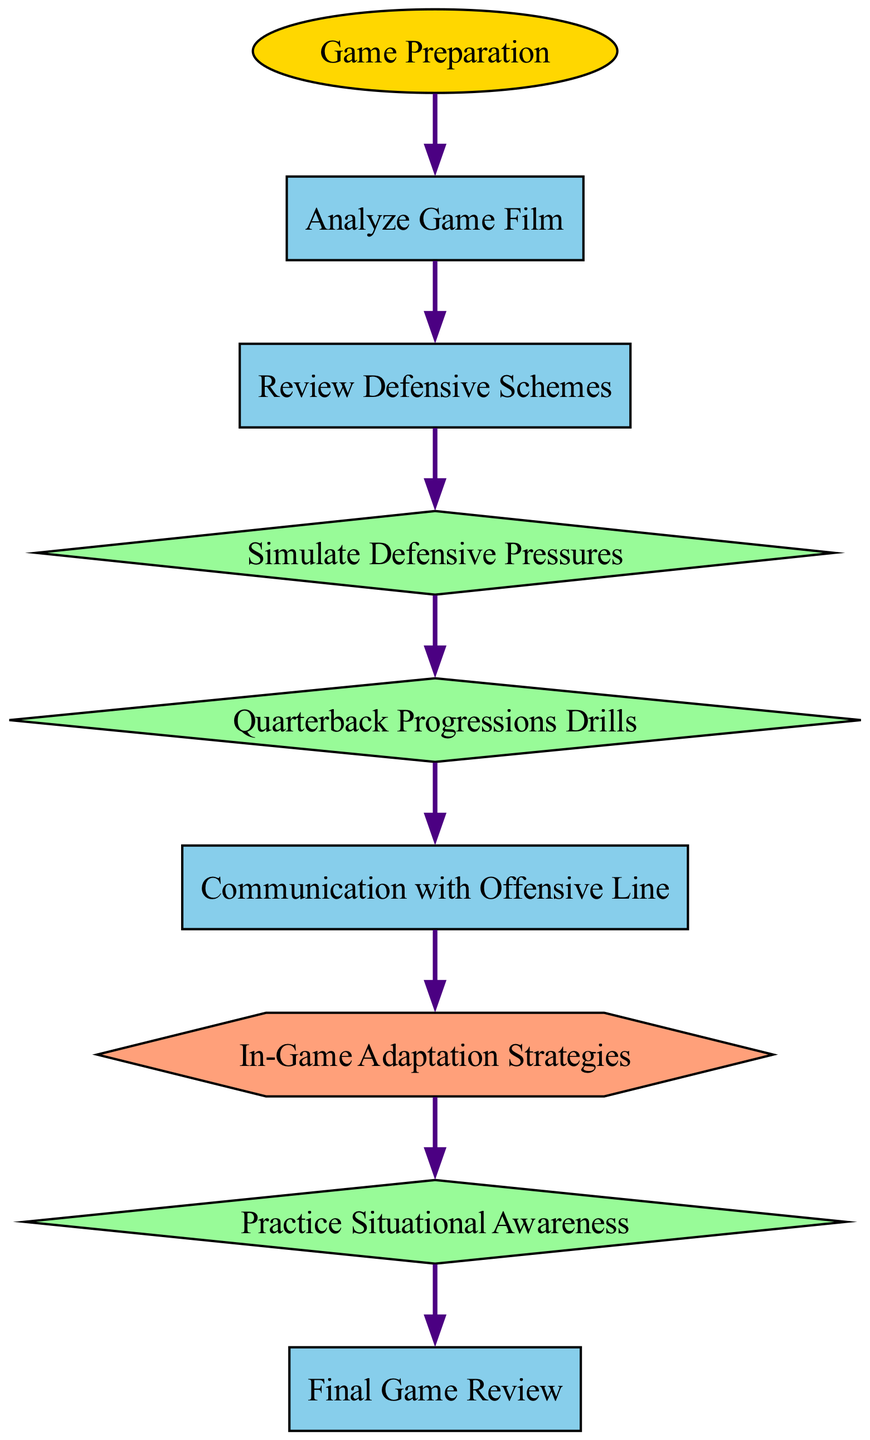What is the first activity in the preparation flow? The first activity is "Analyze Game Film," which is directly dependent on the "Game Preparation" process.
Answer: Analyze Game Film How many drills are included in the preparation flow? There are three drills present in the flow: "Simulate Defensive Pressures," "Quarterback Progressions Drills," and "Practice Situational Awareness."
Answer: Three What is the connection between "In-Game Adaptation Strategies" and "Communication with Offensive Line"? "In-Game Adaptation Strategies" is dependent on "Communication with Offensive Line," indicating that the latter must be completed before the former can begin.
Answer: Dependency Which activity follows "Review Defensive Schemes"? The activity that follows "Review Defensive Schemes" is "Simulate Defensive Pressures," as it directly depends on the completion of the former activity.
Answer: Simulate Defensive Pressures How does the number of nodes compare to the number of edges? There are eight nodes and seven edges in the diagram; the edges represent the dependencies connecting the nodes, indicating a structured flow.
Answer: More nodes What is the final step in the game preparation flow? The final step in the preparation flow is "Final Game Review," following the completion of "Practice Situational Awareness."
Answer: Final Game Review Which drill is performed immediately after simulating defensive pressures? The drill performed immediately after "Simulate Defensive Pressures" is "Quarterback Progressions Drills," as per the dependencies outlined in the diagram.
Answer: Quarterback Progressions Drills What type of node is "Game Preparation"? "Game Preparation" is categorized as a process type node, as indicated by its shape and color in the diagram.
Answer: Process What do "Practice Situational Awareness" and "Final Game Review" have in common regarding their dependencies? Both "Practice Situational Awareness" and "Final Game Review" are linked sequentially, where the former must be completed before the latter can happen, following an unbroken chain of activities.
Answer: Sequential Dependency 